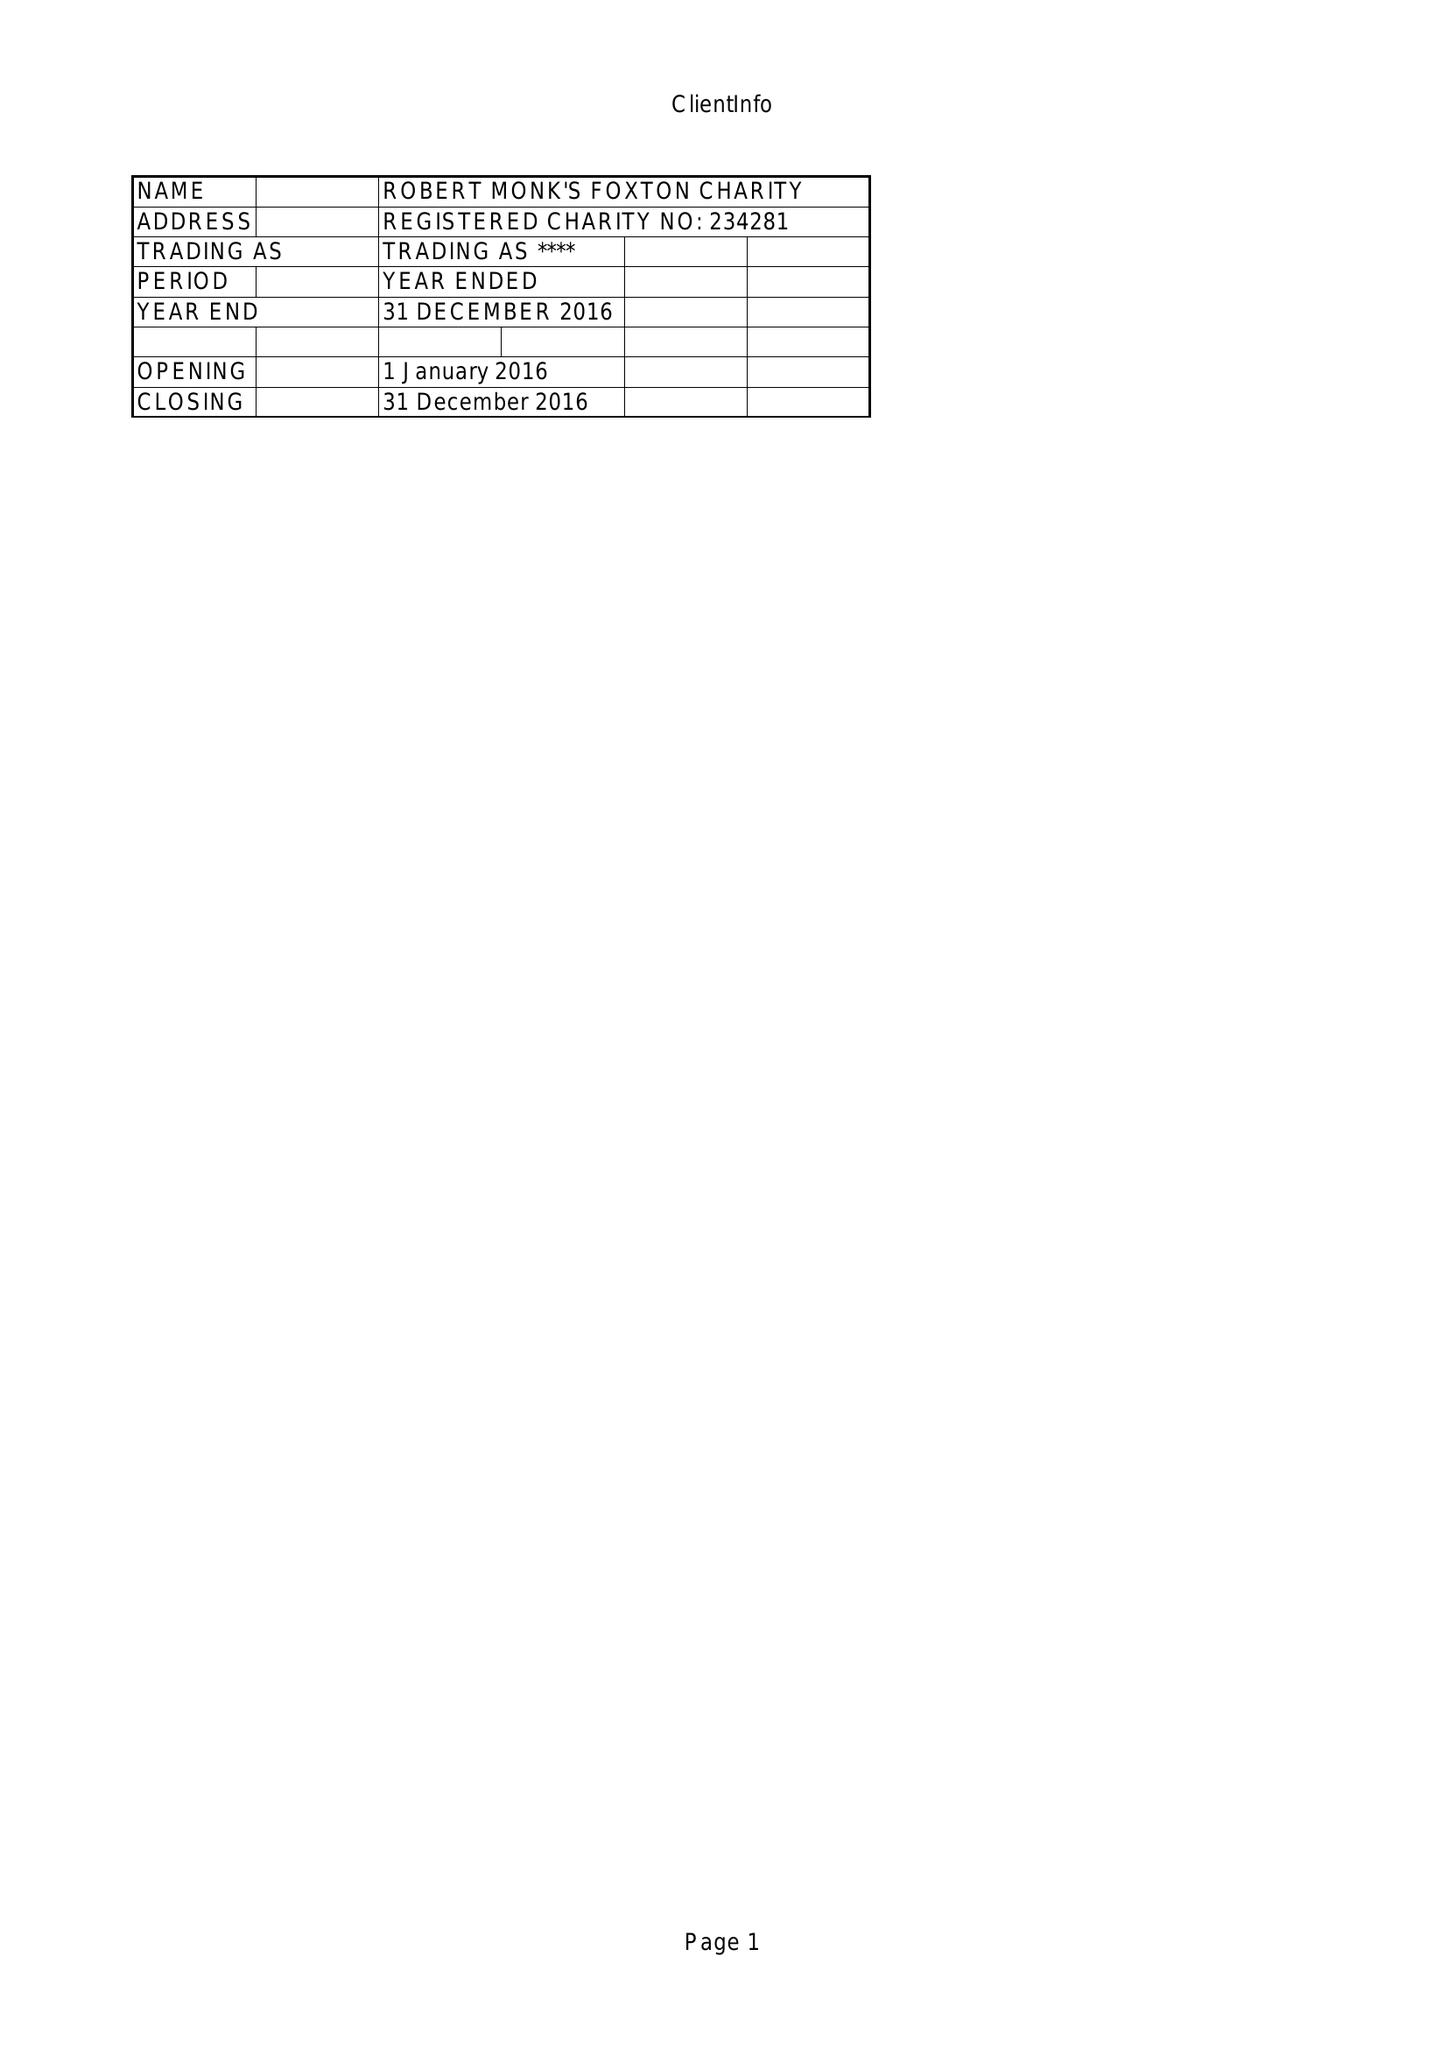What is the value for the income_annually_in_british_pounds?
Answer the question using a single word or phrase. 33254.00 